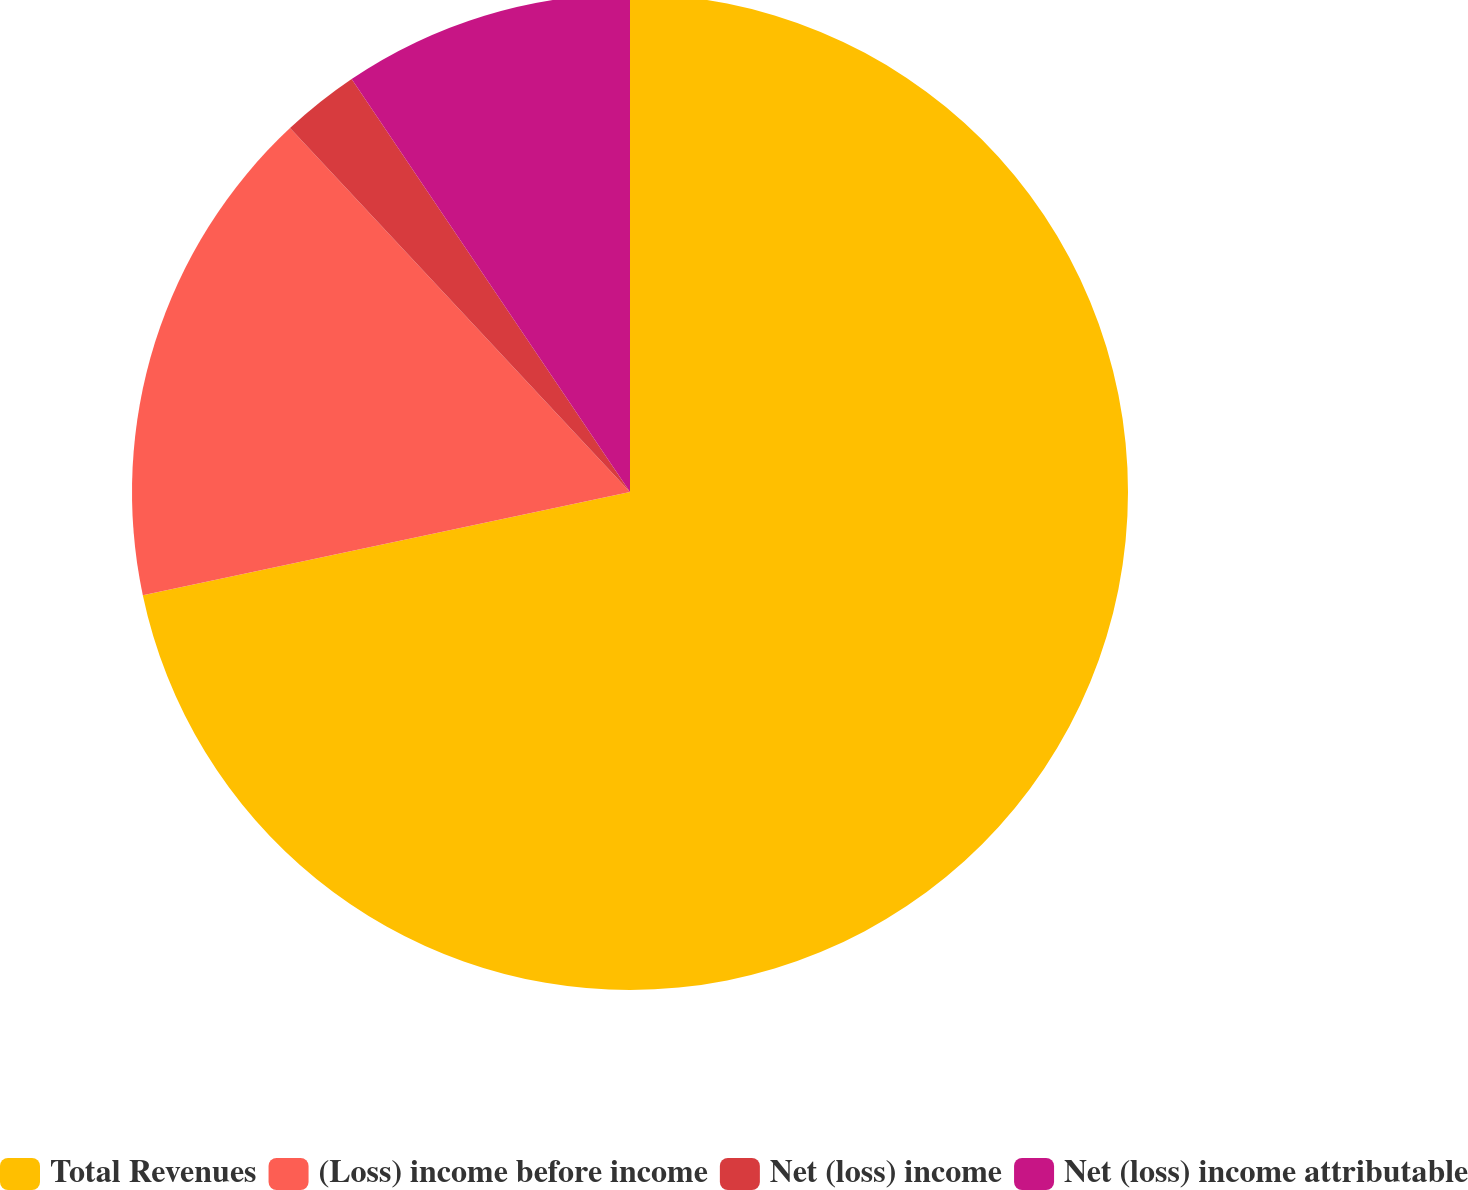<chart> <loc_0><loc_0><loc_500><loc_500><pie_chart><fcel>Total Revenues<fcel>(Loss) income before income<fcel>Net (loss) income<fcel>Net (loss) income attributable<nl><fcel>71.68%<fcel>16.36%<fcel>2.52%<fcel>9.44%<nl></chart> 